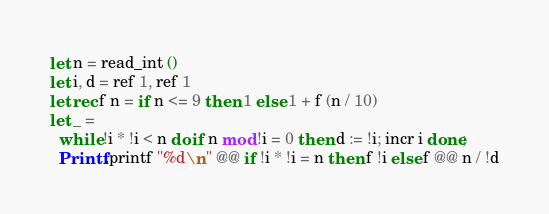<code> <loc_0><loc_0><loc_500><loc_500><_OCaml_>let n = read_int ()
let i, d = ref 1, ref 1
let rec f n = if n <= 9 then 1 else 1 + f (n / 10)
let _ =
  while !i * !i < n do if n mod !i = 0 then d := !i; incr i done;
  Printf.printf "%d\n" @@ if !i * !i = n then f !i else f @@ n / !d</code> 